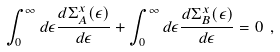Convert formula to latex. <formula><loc_0><loc_0><loc_500><loc_500>\int _ { 0 } ^ { \infty } d \epsilon \frac { d \Sigma _ { A } ^ { x } ( \epsilon ) } { d \epsilon } + \int _ { 0 } ^ { \infty } d \epsilon \frac { d \Sigma _ { B } ^ { x } ( \epsilon ) } { d \epsilon } = 0 \ ,</formula> 